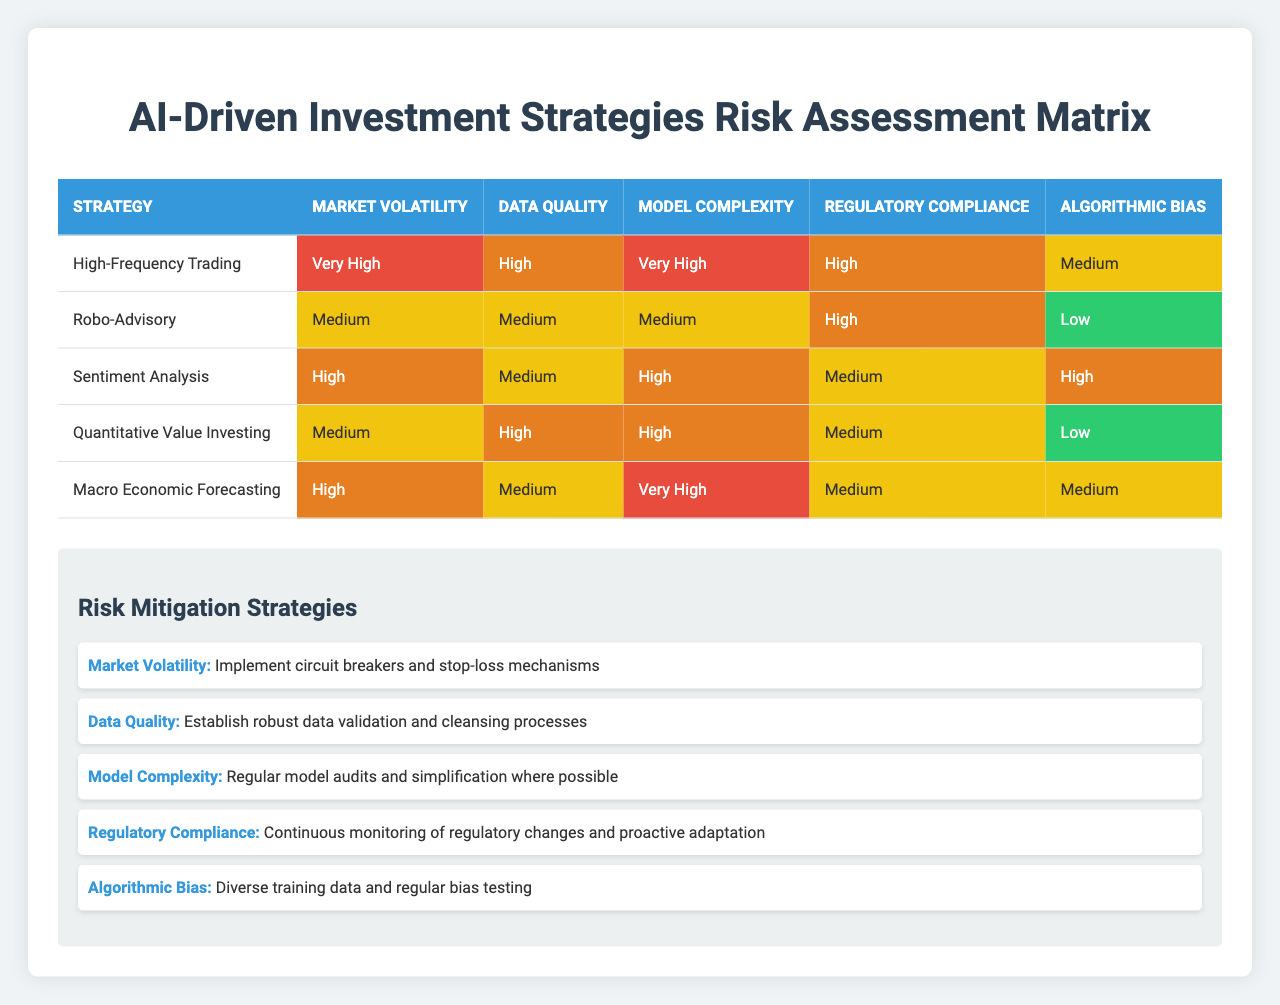What is the risk level for High-Frequency Trading regarding Market Volatility? The table indicates that the risk level for High-Frequency Trading under the Market Volatility factor is categorized as "Very High".
Answer: Very High Which investment strategy has the highest risk level for Algorithmic Bias? By examining the table, Sentiment Analysis has the highest risk level for Algorithmic Bias, categorized as "High".
Answer: High How many investment strategies have a Medium risk level for Data Quality? From the table, we can identify the strategies: Robo-Advisory and Macro Economic Forecasting have a Medium risk level for Data Quality. This totals two strategies.
Answer: 2 Is the risk level for Regulatory Compliance the same for Robo-Advisory and Quantitative Value Investing? The table shows that the risk level for Regulatory Compliance is "High" for Robo-Advisory and "Medium" for Quantitative Value Investing, thus making them different.
Answer: No What is the average risk level for Market Volatility across all strategies? The risk levels for Market Volatility are: Very High (High-Frequency Trading), Medium (Robo-Advisory), High (Sentiment Analysis), Medium (Quantitative Value Investing), and High (Macro Economic Forecasting). Converting these levels to a scale (Very High = 4, High = 3, Medium = 2) gives us (4 + 2 + 3 + 2 + 3) / 5 = 2.8. Rounding this gives us Medium as the average risk level.
Answer: Medium 